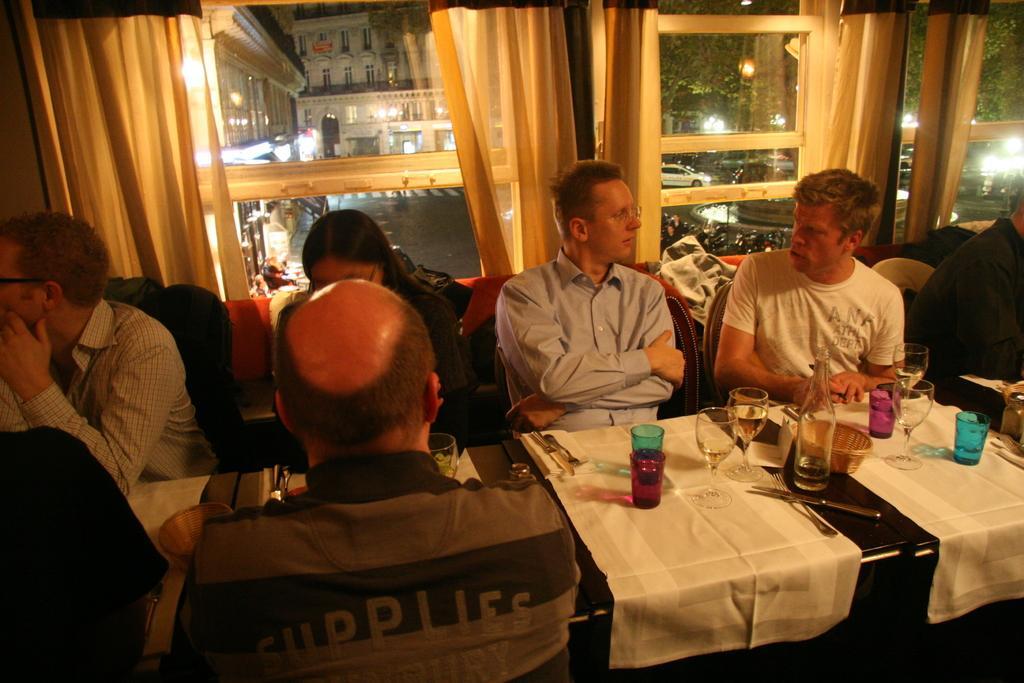Can you describe this image briefly? In the picture we can see some people are sitting on a chairs near the table. On the table we can find white cloth, glasses, bottles, and bowl, with knife and spoons. In the background we can find a window with curtains, from the window we can find some building with lights and cars. 